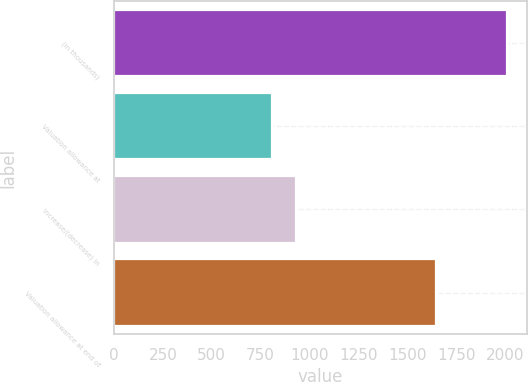Convert chart. <chart><loc_0><loc_0><loc_500><loc_500><bar_chart><fcel>(in thousands)<fcel>Valuation allowance at<fcel>Increase/(decrease) in<fcel>Valuation allowance at end of<nl><fcel>2011<fcel>810<fcel>930.1<fcel>1646<nl></chart> 